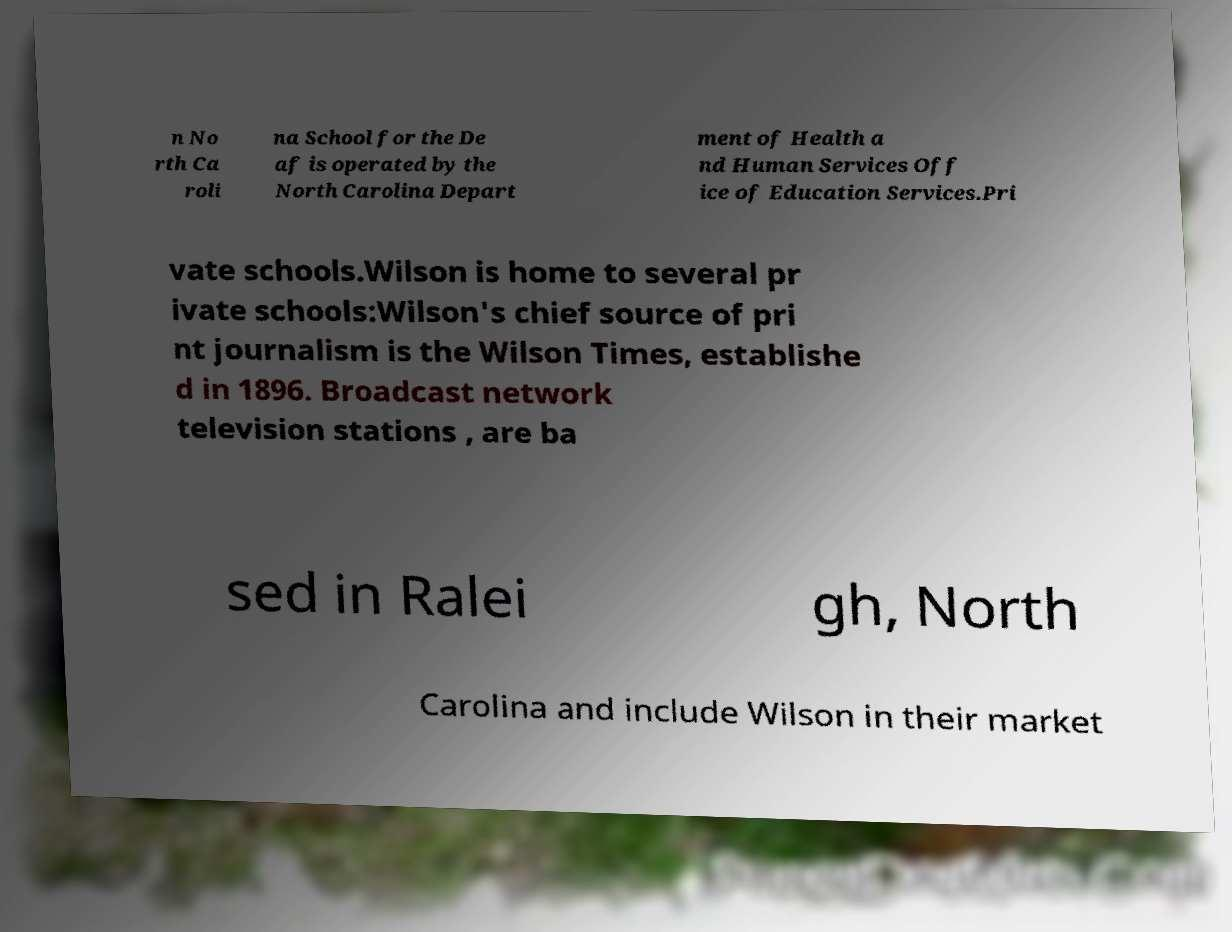Please identify and transcribe the text found in this image. n No rth Ca roli na School for the De af is operated by the North Carolina Depart ment of Health a nd Human Services Off ice of Education Services.Pri vate schools.Wilson is home to several pr ivate schools:Wilson's chief source of pri nt journalism is the Wilson Times, establishe d in 1896. Broadcast network television stations , are ba sed in Ralei gh, North Carolina and include Wilson in their market 